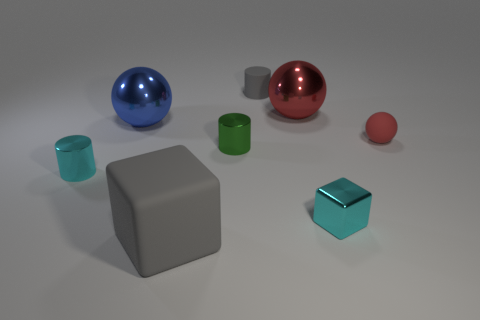Are there fewer spheres in front of the cyan shiny block than tiny gray matte cylinders?
Your answer should be compact. Yes. What is the size of the gray rubber cube left of the gray thing that is behind the big blue metal ball?
Give a very brief answer. Large. There is a rubber cylinder; does it have the same color as the big object in front of the blue metal thing?
Your response must be concise. Yes. There is a cyan object that is the same size as the shiny block; what material is it?
Provide a short and direct response. Metal. Are there fewer red shiny spheres that are in front of the large red metallic object than tiny cylinders on the left side of the large rubber object?
Offer a very short reply. Yes. The tiny cyan shiny thing that is on the right side of the small gray object behind the small ball is what shape?
Your answer should be compact. Cube. Are any small brown metallic cubes visible?
Offer a terse response. No. What is the color of the cylinder behind the tiny ball?
Your answer should be compact. Gray. There is a thing that is the same color as the small sphere; what material is it?
Provide a succinct answer. Metal. Are there any gray objects to the left of the gray rubber cylinder?
Keep it short and to the point. Yes. 